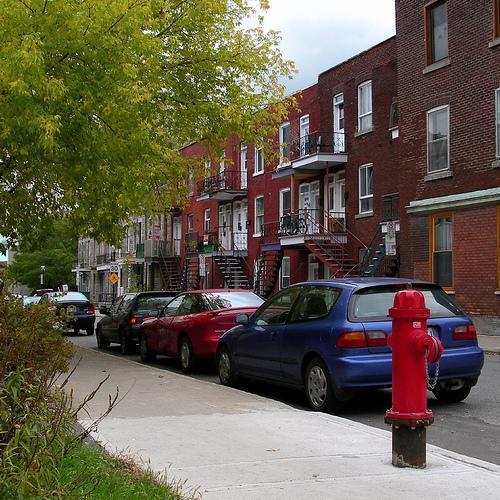How many cars are the same color as the fire hydrant?
Give a very brief answer. 1. How many cars are pictured?
Give a very brief answer. 4. How many cars in the photo?
Give a very brief answer. 4. How many cars are there?
Give a very brief answer. 3. How many people are in photograph?
Give a very brief answer. 0. 